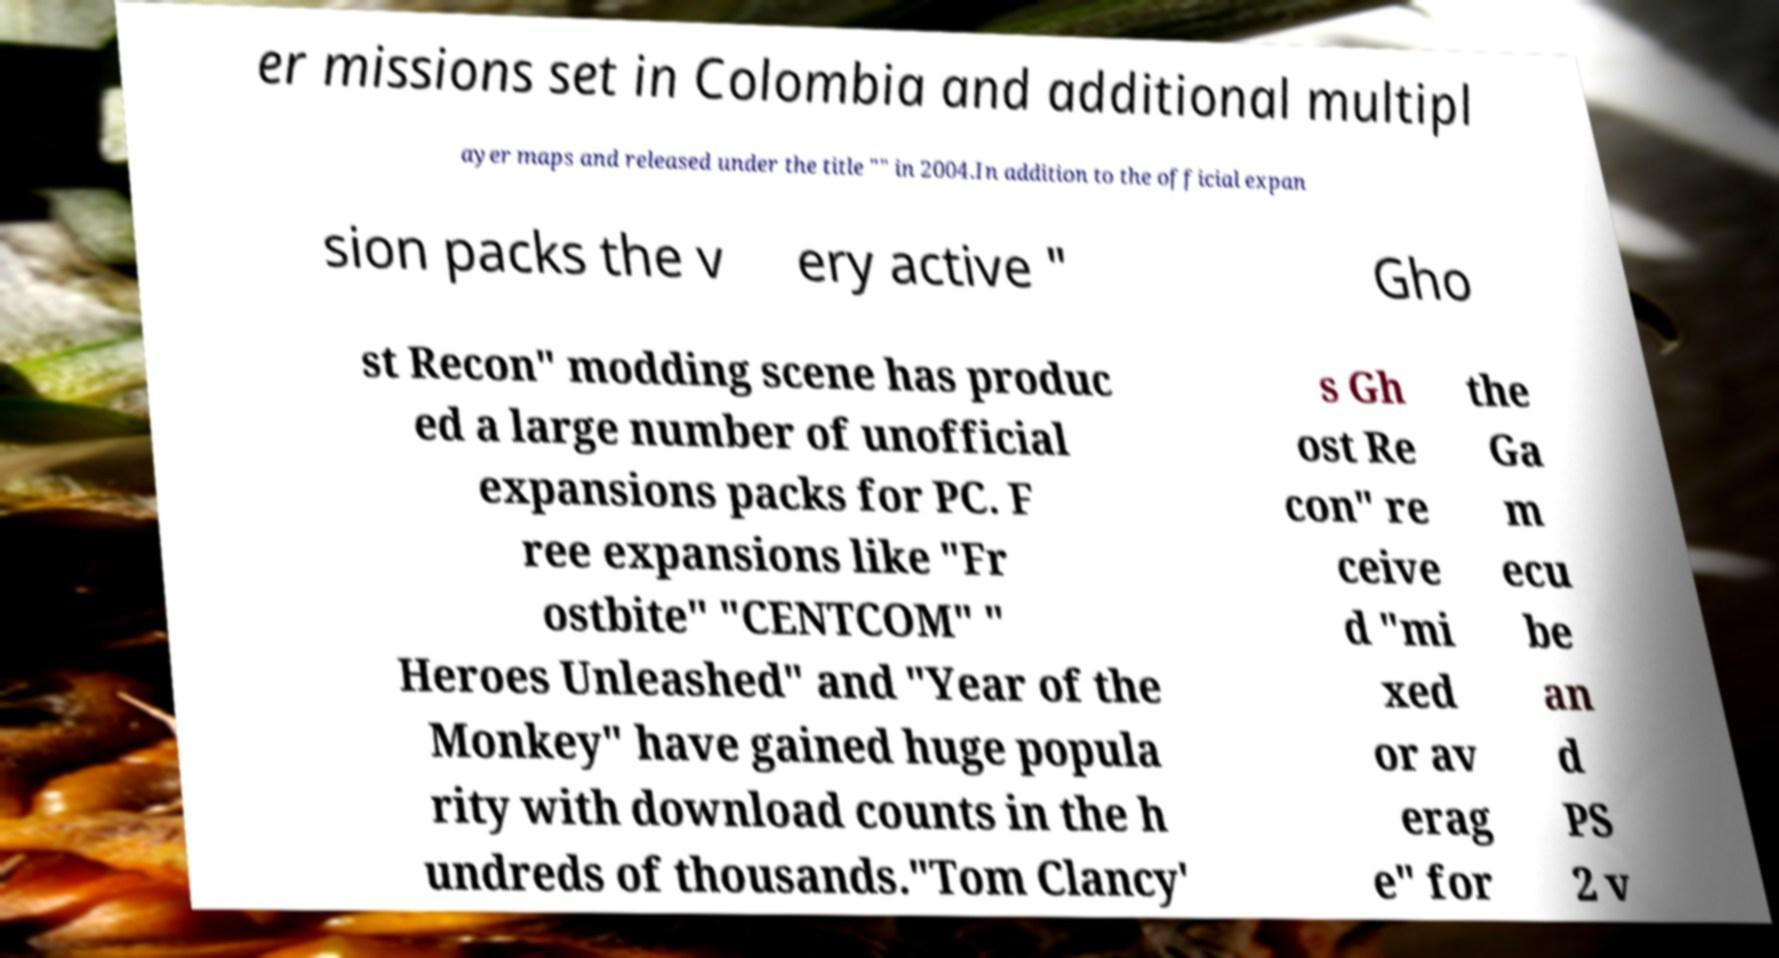Please read and relay the text visible in this image. What does it say? er missions set in Colombia and additional multipl ayer maps and released under the title "" in 2004.In addition to the official expan sion packs the v ery active " Gho st Recon" modding scene has produc ed a large number of unofficial expansions packs for PC. F ree expansions like "Fr ostbite" "CENTCOM" " Heroes Unleashed" and "Year of the Monkey" have gained huge popula rity with download counts in the h undreds of thousands."Tom Clancy' s Gh ost Re con" re ceive d "mi xed or av erag e" for the Ga m ecu be an d PS 2 v 